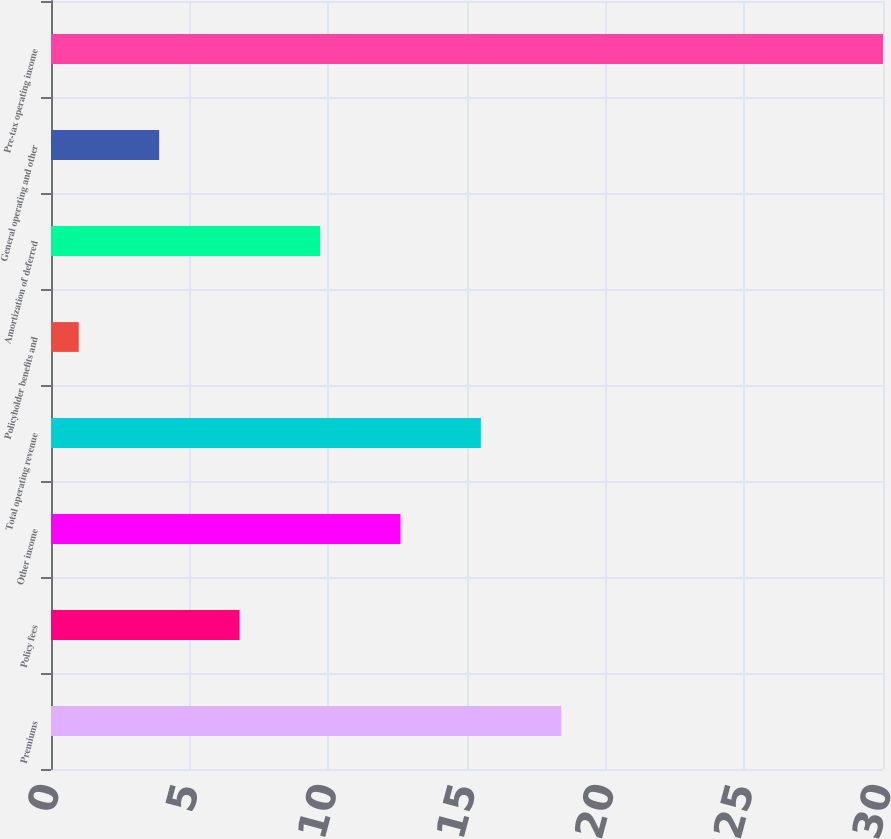<chart> <loc_0><loc_0><loc_500><loc_500><bar_chart><fcel>Premiums<fcel>Policy fees<fcel>Other income<fcel>Total operating revenue<fcel>Policyholder benefits and<fcel>Amortization of deferred<fcel>General operating and other<fcel>Pre-tax operating income<nl><fcel>18.4<fcel>6.8<fcel>12.6<fcel>15.5<fcel>1<fcel>9.7<fcel>3.9<fcel>30<nl></chart> 